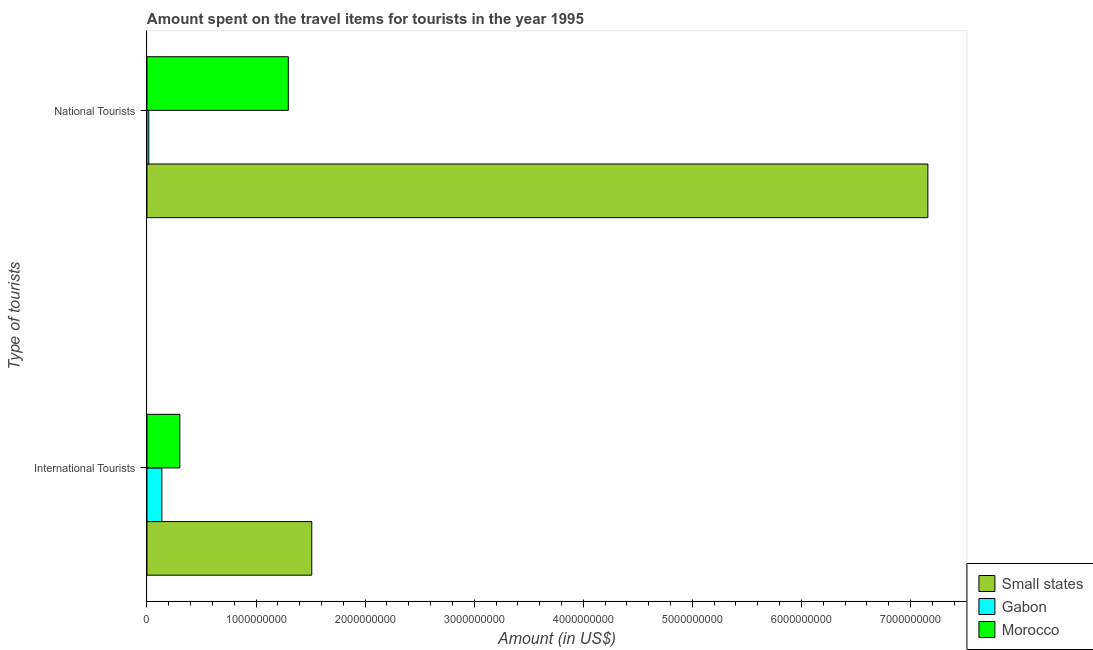How many different coloured bars are there?
Your answer should be compact. 3. Are the number of bars per tick equal to the number of legend labels?
Offer a very short reply. Yes. What is the label of the 2nd group of bars from the top?
Give a very brief answer. International Tourists. What is the amount spent on travel items of national tourists in Small states?
Provide a short and direct response. 7.16e+09. Across all countries, what is the maximum amount spent on travel items of national tourists?
Provide a short and direct response. 7.16e+09. Across all countries, what is the minimum amount spent on travel items of international tourists?
Your response must be concise. 1.37e+08. In which country was the amount spent on travel items of national tourists maximum?
Provide a short and direct response. Small states. In which country was the amount spent on travel items of international tourists minimum?
Provide a succinct answer. Gabon. What is the total amount spent on travel items of international tourists in the graph?
Offer a terse response. 1.95e+09. What is the difference between the amount spent on travel items of national tourists in Gabon and that in Morocco?
Your answer should be compact. -1.28e+09. What is the difference between the amount spent on travel items of national tourists in Small states and the amount spent on travel items of international tourists in Gabon?
Offer a terse response. 7.02e+09. What is the average amount spent on travel items of international tourists per country?
Keep it short and to the point. 6.50e+08. What is the difference between the amount spent on travel items of international tourists and amount spent on travel items of national tourists in Small states?
Provide a succinct answer. -5.65e+09. What is the ratio of the amount spent on travel items of international tourists in Gabon to that in Small states?
Offer a terse response. 0.09. In how many countries, is the amount spent on travel items of national tourists greater than the average amount spent on travel items of national tourists taken over all countries?
Make the answer very short. 1. What does the 3rd bar from the top in National Tourists represents?
Ensure brevity in your answer.  Small states. What does the 2nd bar from the bottom in International Tourists represents?
Offer a terse response. Gabon. Are the values on the major ticks of X-axis written in scientific E-notation?
Your answer should be compact. No. Does the graph contain grids?
Give a very brief answer. No. Where does the legend appear in the graph?
Provide a short and direct response. Bottom right. How many legend labels are there?
Your answer should be compact. 3. How are the legend labels stacked?
Provide a short and direct response. Vertical. What is the title of the graph?
Ensure brevity in your answer.  Amount spent on the travel items for tourists in the year 1995. Does "Chile" appear as one of the legend labels in the graph?
Offer a terse response. No. What is the label or title of the Y-axis?
Offer a terse response. Type of tourists. What is the Amount (in US$) of Small states in International Tourists?
Offer a terse response. 1.51e+09. What is the Amount (in US$) of Gabon in International Tourists?
Give a very brief answer. 1.37e+08. What is the Amount (in US$) of Morocco in International Tourists?
Ensure brevity in your answer.  3.02e+08. What is the Amount (in US$) of Small states in National Tourists?
Keep it short and to the point. 7.16e+09. What is the Amount (in US$) in Gabon in National Tourists?
Your answer should be very brief. 1.70e+07. What is the Amount (in US$) in Morocco in National Tourists?
Make the answer very short. 1.30e+09. Across all Type of tourists, what is the maximum Amount (in US$) of Small states?
Keep it short and to the point. 7.16e+09. Across all Type of tourists, what is the maximum Amount (in US$) in Gabon?
Ensure brevity in your answer.  1.37e+08. Across all Type of tourists, what is the maximum Amount (in US$) in Morocco?
Offer a terse response. 1.30e+09. Across all Type of tourists, what is the minimum Amount (in US$) in Small states?
Offer a very short reply. 1.51e+09. Across all Type of tourists, what is the minimum Amount (in US$) in Gabon?
Your answer should be very brief. 1.70e+07. Across all Type of tourists, what is the minimum Amount (in US$) in Morocco?
Your response must be concise. 3.02e+08. What is the total Amount (in US$) of Small states in the graph?
Keep it short and to the point. 8.67e+09. What is the total Amount (in US$) of Gabon in the graph?
Keep it short and to the point. 1.54e+08. What is the total Amount (in US$) in Morocco in the graph?
Make the answer very short. 1.60e+09. What is the difference between the Amount (in US$) of Small states in International Tourists and that in National Tourists?
Keep it short and to the point. -5.65e+09. What is the difference between the Amount (in US$) of Gabon in International Tourists and that in National Tourists?
Provide a short and direct response. 1.20e+08. What is the difference between the Amount (in US$) of Morocco in International Tourists and that in National Tourists?
Offer a very short reply. -9.94e+08. What is the difference between the Amount (in US$) of Small states in International Tourists and the Amount (in US$) of Gabon in National Tourists?
Ensure brevity in your answer.  1.49e+09. What is the difference between the Amount (in US$) in Small states in International Tourists and the Amount (in US$) in Morocco in National Tourists?
Make the answer very short. 2.15e+08. What is the difference between the Amount (in US$) in Gabon in International Tourists and the Amount (in US$) in Morocco in National Tourists?
Keep it short and to the point. -1.16e+09. What is the average Amount (in US$) of Small states per Type of tourists?
Ensure brevity in your answer.  4.34e+09. What is the average Amount (in US$) of Gabon per Type of tourists?
Your answer should be compact. 7.70e+07. What is the average Amount (in US$) in Morocco per Type of tourists?
Your response must be concise. 7.99e+08. What is the difference between the Amount (in US$) in Small states and Amount (in US$) in Gabon in International Tourists?
Your response must be concise. 1.37e+09. What is the difference between the Amount (in US$) in Small states and Amount (in US$) in Morocco in International Tourists?
Your answer should be very brief. 1.21e+09. What is the difference between the Amount (in US$) of Gabon and Amount (in US$) of Morocco in International Tourists?
Keep it short and to the point. -1.65e+08. What is the difference between the Amount (in US$) in Small states and Amount (in US$) in Gabon in National Tourists?
Keep it short and to the point. 7.14e+09. What is the difference between the Amount (in US$) in Small states and Amount (in US$) in Morocco in National Tourists?
Provide a short and direct response. 5.86e+09. What is the difference between the Amount (in US$) of Gabon and Amount (in US$) of Morocco in National Tourists?
Ensure brevity in your answer.  -1.28e+09. What is the ratio of the Amount (in US$) in Small states in International Tourists to that in National Tourists?
Give a very brief answer. 0.21. What is the ratio of the Amount (in US$) in Gabon in International Tourists to that in National Tourists?
Make the answer very short. 8.06. What is the ratio of the Amount (in US$) of Morocco in International Tourists to that in National Tourists?
Give a very brief answer. 0.23. What is the difference between the highest and the second highest Amount (in US$) in Small states?
Offer a very short reply. 5.65e+09. What is the difference between the highest and the second highest Amount (in US$) of Gabon?
Offer a terse response. 1.20e+08. What is the difference between the highest and the second highest Amount (in US$) in Morocco?
Provide a succinct answer. 9.94e+08. What is the difference between the highest and the lowest Amount (in US$) of Small states?
Your answer should be very brief. 5.65e+09. What is the difference between the highest and the lowest Amount (in US$) in Gabon?
Ensure brevity in your answer.  1.20e+08. What is the difference between the highest and the lowest Amount (in US$) in Morocco?
Your answer should be compact. 9.94e+08. 